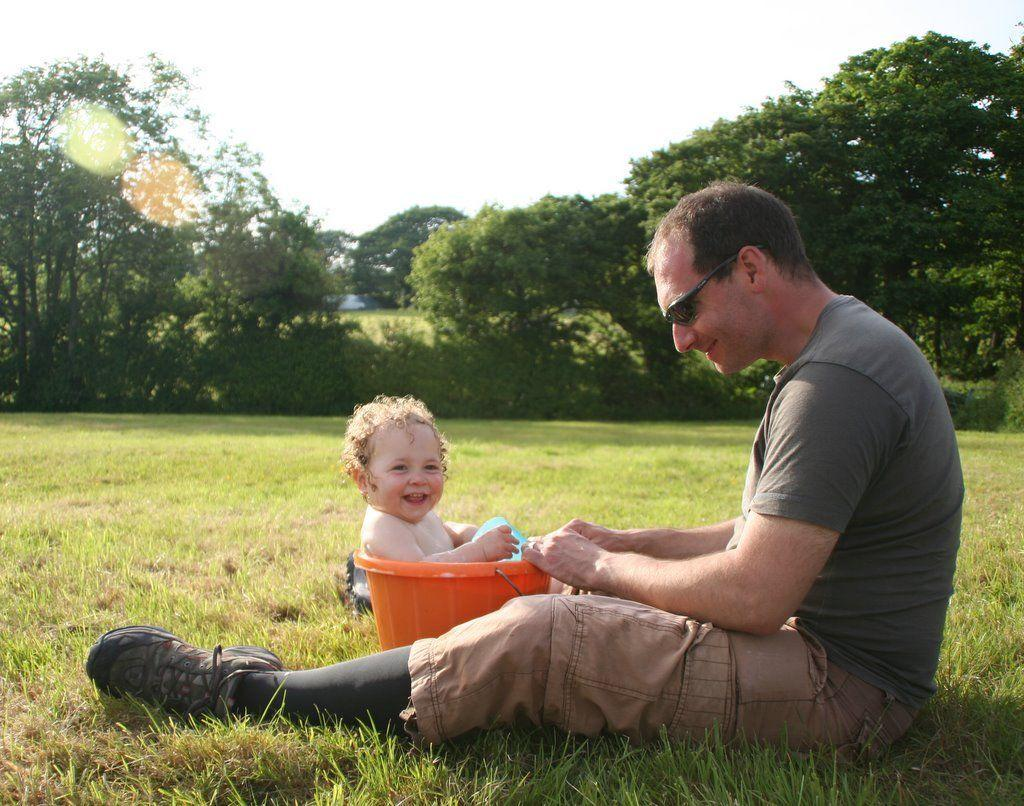What is the person in the image wearing on their face? The person is wearing goggles. What type of footwear is the person wearing? The person is wearing shoes. What type of clothing is the person wearing on their upper body? The person is wearing a shirt. Where is the person sitting in the image? The person is sitting on grassy land. What object can be seen in the image besides the person? There is a bucket in the image. What is inside the bucket? The bucket has a kid in it. What can be seen in the background of the image? There are trees and the sky visible in the background of the image. What type of store can be seen in the background of the image? There is no store visible in the background of the image; only trees and the sky are present. What type of wool is the person wearing in the image? The person is not wearing wool in the image; they are wearing a shirt. 